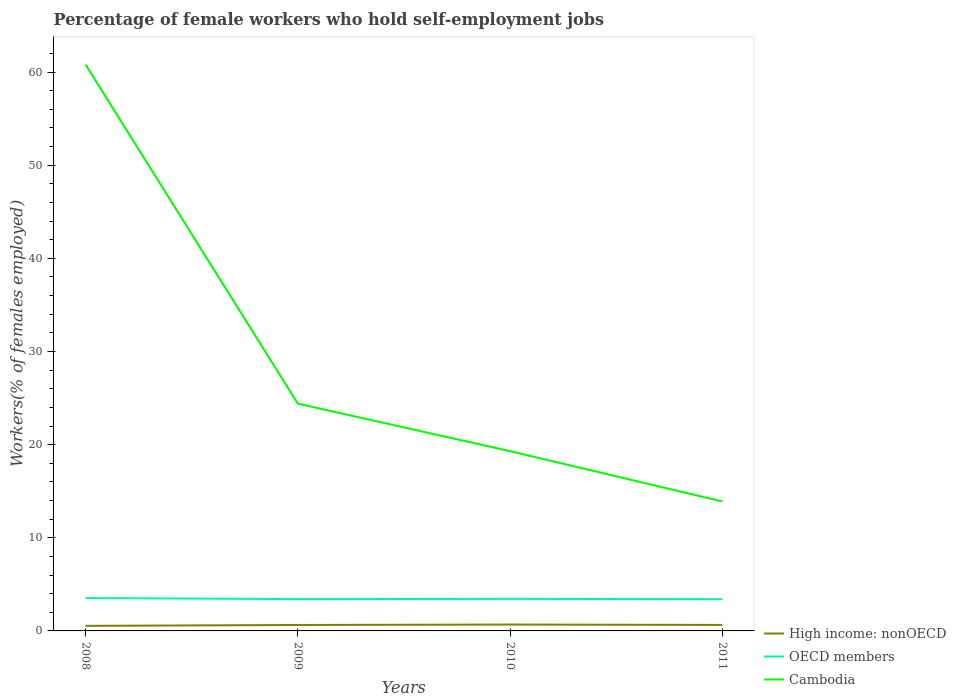Does the line corresponding to Cambodia intersect with the line corresponding to High income: nonOECD?
Your answer should be very brief. No. Across all years, what is the maximum percentage of self-employed female workers in Cambodia?
Provide a short and direct response. 13.9. What is the total percentage of self-employed female workers in Cambodia in the graph?
Your response must be concise. 5.1. What is the difference between the highest and the second highest percentage of self-employed female workers in OECD members?
Keep it short and to the point. 0.12. How many lines are there?
Your response must be concise. 3. How many years are there in the graph?
Your answer should be very brief. 4. Are the values on the major ticks of Y-axis written in scientific E-notation?
Keep it short and to the point. No. Does the graph contain any zero values?
Ensure brevity in your answer.  No. Does the graph contain grids?
Give a very brief answer. No. Where does the legend appear in the graph?
Keep it short and to the point. Bottom right. What is the title of the graph?
Offer a very short reply. Percentage of female workers who hold self-employment jobs. What is the label or title of the Y-axis?
Ensure brevity in your answer.  Workers(% of females employed). What is the Workers(% of females employed) in High income: nonOECD in 2008?
Keep it short and to the point. 0.54. What is the Workers(% of females employed) of OECD members in 2008?
Your response must be concise. 3.53. What is the Workers(% of females employed) in Cambodia in 2008?
Offer a terse response. 60.8. What is the Workers(% of females employed) of High income: nonOECD in 2009?
Give a very brief answer. 0.64. What is the Workers(% of females employed) of OECD members in 2009?
Keep it short and to the point. 3.41. What is the Workers(% of females employed) in Cambodia in 2009?
Offer a terse response. 24.4. What is the Workers(% of females employed) of High income: nonOECD in 2010?
Offer a very short reply. 0.68. What is the Workers(% of females employed) of OECD members in 2010?
Provide a short and direct response. 3.44. What is the Workers(% of females employed) in Cambodia in 2010?
Provide a short and direct response. 19.3. What is the Workers(% of females employed) in High income: nonOECD in 2011?
Give a very brief answer. 0.64. What is the Workers(% of females employed) of OECD members in 2011?
Give a very brief answer. 3.41. What is the Workers(% of females employed) of Cambodia in 2011?
Give a very brief answer. 13.9. Across all years, what is the maximum Workers(% of females employed) in High income: nonOECD?
Your answer should be compact. 0.68. Across all years, what is the maximum Workers(% of females employed) in OECD members?
Your answer should be very brief. 3.53. Across all years, what is the maximum Workers(% of females employed) of Cambodia?
Give a very brief answer. 60.8. Across all years, what is the minimum Workers(% of females employed) of High income: nonOECD?
Provide a succinct answer. 0.54. Across all years, what is the minimum Workers(% of females employed) of OECD members?
Your response must be concise. 3.41. Across all years, what is the minimum Workers(% of females employed) in Cambodia?
Provide a succinct answer. 13.9. What is the total Workers(% of females employed) of High income: nonOECD in the graph?
Ensure brevity in your answer.  2.51. What is the total Workers(% of females employed) of OECD members in the graph?
Your answer should be compact. 13.79. What is the total Workers(% of females employed) of Cambodia in the graph?
Provide a short and direct response. 118.4. What is the difference between the Workers(% of females employed) in High income: nonOECD in 2008 and that in 2009?
Keep it short and to the point. -0.09. What is the difference between the Workers(% of females employed) in OECD members in 2008 and that in 2009?
Keep it short and to the point. 0.12. What is the difference between the Workers(% of females employed) of Cambodia in 2008 and that in 2009?
Ensure brevity in your answer.  36.4. What is the difference between the Workers(% of females employed) in High income: nonOECD in 2008 and that in 2010?
Provide a short and direct response. -0.14. What is the difference between the Workers(% of females employed) in OECD members in 2008 and that in 2010?
Ensure brevity in your answer.  0.09. What is the difference between the Workers(% of females employed) in Cambodia in 2008 and that in 2010?
Give a very brief answer. 41.5. What is the difference between the Workers(% of females employed) in High income: nonOECD in 2008 and that in 2011?
Ensure brevity in your answer.  -0.1. What is the difference between the Workers(% of females employed) of OECD members in 2008 and that in 2011?
Ensure brevity in your answer.  0.12. What is the difference between the Workers(% of females employed) in Cambodia in 2008 and that in 2011?
Your response must be concise. 46.9. What is the difference between the Workers(% of females employed) of High income: nonOECD in 2009 and that in 2010?
Offer a very short reply. -0.05. What is the difference between the Workers(% of females employed) in OECD members in 2009 and that in 2010?
Make the answer very short. -0.02. What is the difference between the Workers(% of females employed) of High income: nonOECD in 2009 and that in 2011?
Keep it short and to the point. -0. What is the difference between the Workers(% of females employed) of OECD members in 2009 and that in 2011?
Your answer should be very brief. 0.01. What is the difference between the Workers(% of females employed) in High income: nonOECD in 2010 and that in 2011?
Offer a very short reply. 0.04. What is the difference between the Workers(% of females employed) in OECD members in 2010 and that in 2011?
Your answer should be compact. 0.03. What is the difference between the Workers(% of females employed) in High income: nonOECD in 2008 and the Workers(% of females employed) in OECD members in 2009?
Make the answer very short. -2.87. What is the difference between the Workers(% of females employed) in High income: nonOECD in 2008 and the Workers(% of females employed) in Cambodia in 2009?
Provide a succinct answer. -23.86. What is the difference between the Workers(% of females employed) of OECD members in 2008 and the Workers(% of females employed) of Cambodia in 2009?
Keep it short and to the point. -20.87. What is the difference between the Workers(% of females employed) of High income: nonOECD in 2008 and the Workers(% of females employed) of OECD members in 2010?
Ensure brevity in your answer.  -2.9. What is the difference between the Workers(% of females employed) of High income: nonOECD in 2008 and the Workers(% of females employed) of Cambodia in 2010?
Your answer should be compact. -18.76. What is the difference between the Workers(% of females employed) of OECD members in 2008 and the Workers(% of females employed) of Cambodia in 2010?
Provide a short and direct response. -15.77. What is the difference between the Workers(% of females employed) in High income: nonOECD in 2008 and the Workers(% of females employed) in OECD members in 2011?
Your answer should be compact. -2.87. What is the difference between the Workers(% of females employed) in High income: nonOECD in 2008 and the Workers(% of females employed) in Cambodia in 2011?
Your answer should be very brief. -13.36. What is the difference between the Workers(% of females employed) in OECD members in 2008 and the Workers(% of females employed) in Cambodia in 2011?
Offer a terse response. -10.37. What is the difference between the Workers(% of females employed) of High income: nonOECD in 2009 and the Workers(% of females employed) of OECD members in 2010?
Provide a short and direct response. -2.8. What is the difference between the Workers(% of females employed) in High income: nonOECD in 2009 and the Workers(% of females employed) in Cambodia in 2010?
Provide a short and direct response. -18.66. What is the difference between the Workers(% of females employed) in OECD members in 2009 and the Workers(% of females employed) in Cambodia in 2010?
Keep it short and to the point. -15.89. What is the difference between the Workers(% of females employed) in High income: nonOECD in 2009 and the Workers(% of females employed) in OECD members in 2011?
Keep it short and to the point. -2.77. What is the difference between the Workers(% of females employed) in High income: nonOECD in 2009 and the Workers(% of females employed) in Cambodia in 2011?
Keep it short and to the point. -13.26. What is the difference between the Workers(% of females employed) of OECD members in 2009 and the Workers(% of females employed) of Cambodia in 2011?
Your response must be concise. -10.49. What is the difference between the Workers(% of females employed) in High income: nonOECD in 2010 and the Workers(% of females employed) in OECD members in 2011?
Your answer should be compact. -2.72. What is the difference between the Workers(% of females employed) of High income: nonOECD in 2010 and the Workers(% of females employed) of Cambodia in 2011?
Your answer should be very brief. -13.22. What is the difference between the Workers(% of females employed) in OECD members in 2010 and the Workers(% of females employed) in Cambodia in 2011?
Offer a terse response. -10.46. What is the average Workers(% of females employed) of High income: nonOECD per year?
Ensure brevity in your answer.  0.63. What is the average Workers(% of females employed) of OECD members per year?
Provide a short and direct response. 3.45. What is the average Workers(% of females employed) in Cambodia per year?
Ensure brevity in your answer.  29.6. In the year 2008, what is the difference between the Workers(% of females employed) in High income: nonOECD and Workers(% of females employed) in OECD members?
Your answer should be compact. -2.99. In the year 2008, what is the difference between the Workers(% of females employed) of High income: nonOECD and Workers(% of females employed) of Cambodia?
Offer a very short reply. -60.26. In the year 2008, what is the difference between the Workers(% of females employed) of OECD members and Workers(% of females employed) of Cambodia?
Your answer should be compact. -57.27. In the year 2009, what is the difference between the Workers(% of females employed) of High income: nonOECD and Workers(% of females employed) of OECD members?
Give a very brief answer. -2.78. In the year 2009, what is the difference between the Workers(% of females employed) of High income: nonOECD and Workers(% of females employed) of Cambodia?
Make the answer very short. -23.76. In the year 2009, what is the difference between the Workers(% of females employed) in OECD members and Workers(% of females employed) in Cambodia?
Your answer should be compact. -20.99. In the year 2010, what is the difference between the Workers(% of females employed) of High income: nonOECD and Workers(% of females employed) of OECD members?
Make the answer very short. -2.75. In the year 2010, what is the difference between the Workers(% of females employed) in High income: nonOECD and Workers(% of females employed) in Cambodia?
Ensure brevity in your answer.  -18.62. In the year 2010, what is the difference between the Workers(% of females employed) in OECD members and Workers(% of females employed) in Cambodia?
Make the answer very short. -15.86. In the year 2011, what is the difference between the Workers(% of females employed) in High income: nonOECD and Workers(% of females employed) in OECD members?
Provide a succinct answer. -2.77. In the year 2011, what is the difference between the Workers(% of females employed) in High income: nonOECD and Workers(% of females employed) in Cambodia?
Your response must be concise. -13.26. In the year 2011, what is the difference between the Workers(% of females employed) of OECD members and Workers(% of females employed) of Cambodia?
Keep it short and to the point. -10.49. What is the ratio of the Workers(% of females employed) in High income: nonOECD in 2008 to that in 2009?
Your answer should be compact. 0.85. What is the ratio of the Workers(% of females employed) in OECD members in 2008 to that in 2009?
Make the answer very short. 1.03. What is the ratio of the Workers(% of females employed) of Cambodia in 2008 to that in 2009?
Provide a short and direct response. 2.49. What is the ratio of the Workers(% of females employed) in High income: nonOECD in 2008 to that in 2010?
Provide a succinct answer. 0.79. What is the ratio of the Workers(% of females employed) of Cambodia in 2008 to that in 2010?
Provide a short and direct response. 3.15. What is the ratio of the Workers(% of females employed) of High income: nonOECD in 2008 to that in 2011?
Provide a succinct answer. 0.85. What is the ratio of the Workers(% of females employed) in OECD members in 2008 to that in 2011?
Provide a succinct answer. 1.04. What is the ratio of the Workers(% of females employed) in Cambodia in 2008 to that in 2011?
Keep it short and to the point. 4.37. What is the ratio of the Workers(% of females employed) in High income: nonOECD in 2009 to that in 2010?
Your response must be concise. 0.93. What is the ratio of the Workers(% of females employed) in Cambodia in 2009 to that in 2010?
Offer a very short reply. 1.26. What is the ratio of the Workers(% of females employed) of Cambodia in 2009 to that in 2011?
Make the answer very short. 1.76. What is the ratio of the Workers(% of females employed) in High income: nonOECD in 2010 to that in 2011?
Offer a terse response. 1.07. What is the ratio of the Workers(% of females employed) in OECD members in 2010 to that in 2011?
Give a very brief answer. 1.01. What is the ratio of the Workers(% of females employed) of Cambodia in 2010 to that in 2011?
Offer a very short reply. 1.39. What is the difference between the highest and the second highest Workers(% of females employed) in High income: nonOECD?
Provide a succinct answer. 0.04. What is the difference between the highest and the second highest Workers(% of females employed) of OECD members?
Keep it short and to the point. 0.09. What is the difference between the highest and the second highest Workers(% of females employed) in Cambodia?
Keep it short and to the point. 36.4. What is the difference between the highest and the lowest Workers(% of females employed) of High income: nonOECD?
Your answer should be very brief. 0.14. What is the difference between the highest and the lowest Workers(% of females employed) in OECD members?
Give a very brief answer. 0.12. What is the difference between the highest and the lowest Workers(% of females employed) in Cambodia?
Your answer should be very brief. 46.9. 